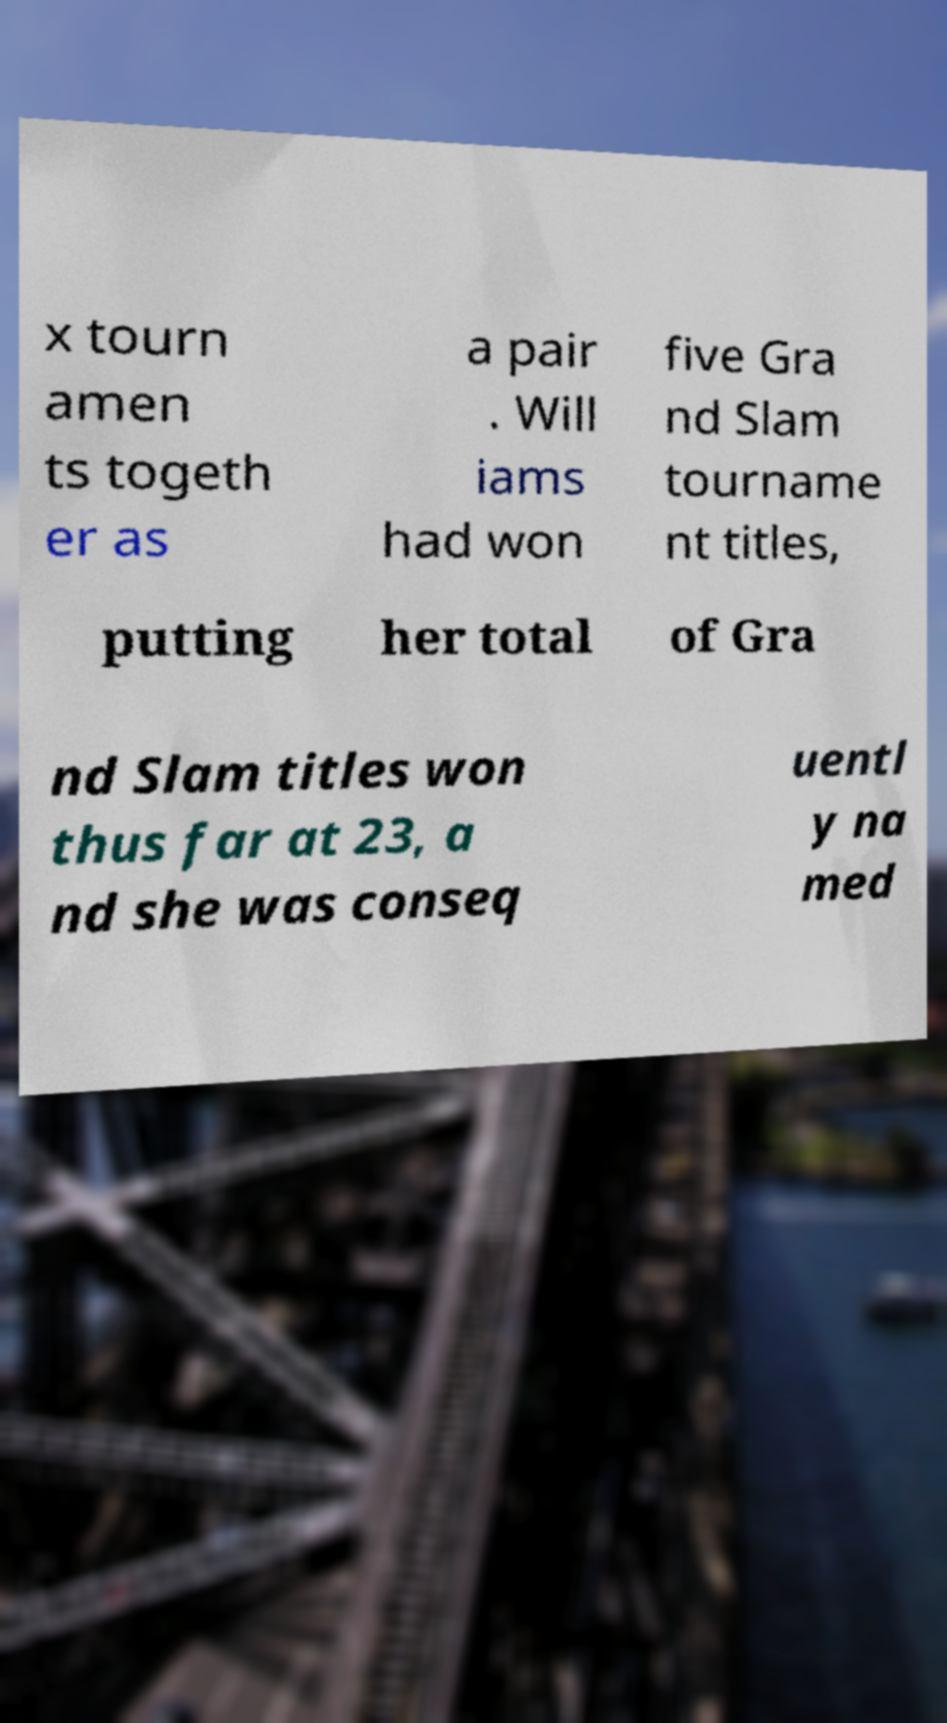There's text embedded in this image that I need extracted. Can you transcribe it verbatim? x tourn amen ts togeth er as a pair . Will iams had won five Gra nd Slam tourname nt titles, putting her total of Gra nd Slam titles won thus far at 23, a nd she was conseq uentl y na med 